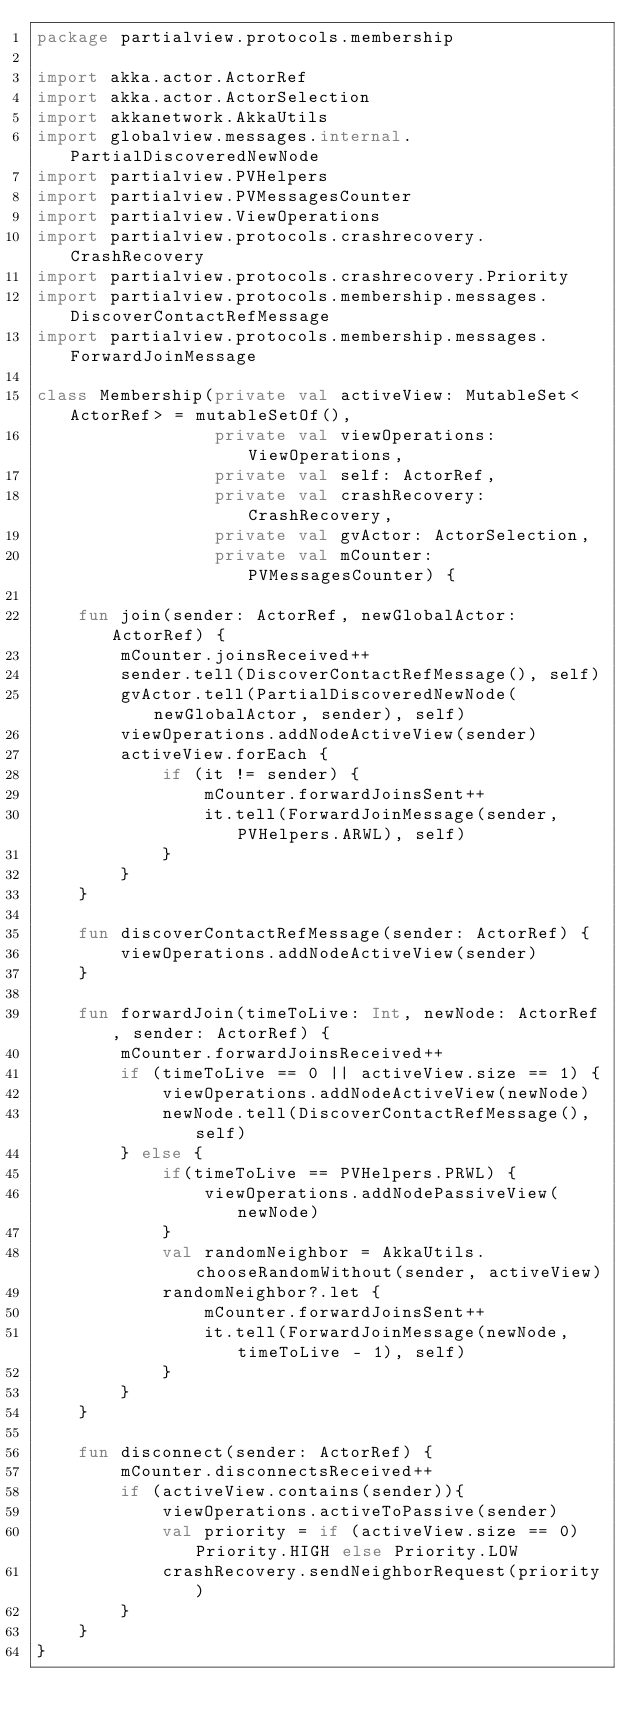Convert code to text. <code><loc_0><loc_0><loc_500><loc_500><_Kotlin_>package partialview.protocols.membership

import akka.actor.ActorRef
import akka.actor.ActorSelection
import akkanetwork.AkkaUtils
import globalview.messages.internal.PartialDiscoveredNewNode
import partialview.PVHelpers
import partialview.PVMessagesCounter
import partialview.ViewOperations
import partialview.protocols.crashrecovery.CrashRecovery
import partialview.protocols.crashrecovery.Priority
import partialview.protocols.membership.messages.DiscoverContactRefMessage
import partialview.protocols.membership.messages.ForwardJoinMessage

class Membership(private val activeView: MutableSet<ActorRef> = mutableSetOf(),
                 private val viewOperations: ViewOperations,
                 private val self: ActorRef,
                 private val crashRecovery: CrashRecovery,
                 private val gvActor: ActorSelection,
                 private val mCounter: PVMessagesCounter) {

    fun join(sender: ActorRef, newGlobalActor: ActorRef) {
        mCounter.joinsReceived++
        sender.tell(DiscoverContactRefMessage(), self)
        gvActor.tell(PartialDiscoveredNewNode(newGlobalActor, sender), self)
        viewOperations.addNodeActiveView(sender)
        activeView.forEach {
            if (it != sender) {
                mCounter.forwardJoinsSent++
                it.tell(ForwardJoinMessage(sender, PVHelpers.ARWL), self)
            }
        }
    }

    fun discoverContactRefMessage(sender: ActorRef) {
        viewOperations.addNodeActiveView(sender)
    }

    fun forwardJoin(timeToLive: Int, newNode: ActorRef, sender: ActorRef) {
        mCounter.forwardJoinsReceived++
        if (timeToLive == 0 || activeView.size == 1) {
            viewOperations.addNodeActiveView(newNode)
            newNode.tell(DiscoverContactRefMessage(), self)
        } else {
            if(timeToLive == PVHelpers.PRWL) {
                viewOperations.addNodePassiveView(newNode)
            }
            val randomNeighbor = AkkaUtils.chooseRandomWithout(sender, activeView)
            randomNeighbor?.let {
                mCounter.forwardJoinsSent++
                it.tell(ForwardJoinMessage(newNode, timeToLive - 1), self)
            }
        }
    }

    fun disconnect(sender: ActorRef) {
        mCounter.disconnectsReceived++
        if (activeView.contains(sender)){
            viewOperations.activeToPassive(sender)
            val priority = if (activeView.size == 0) Priority.HIGH else Priority.LOW
            crashRecovery.sendNeighborRequest(priority)
        }
    }
}</code> 